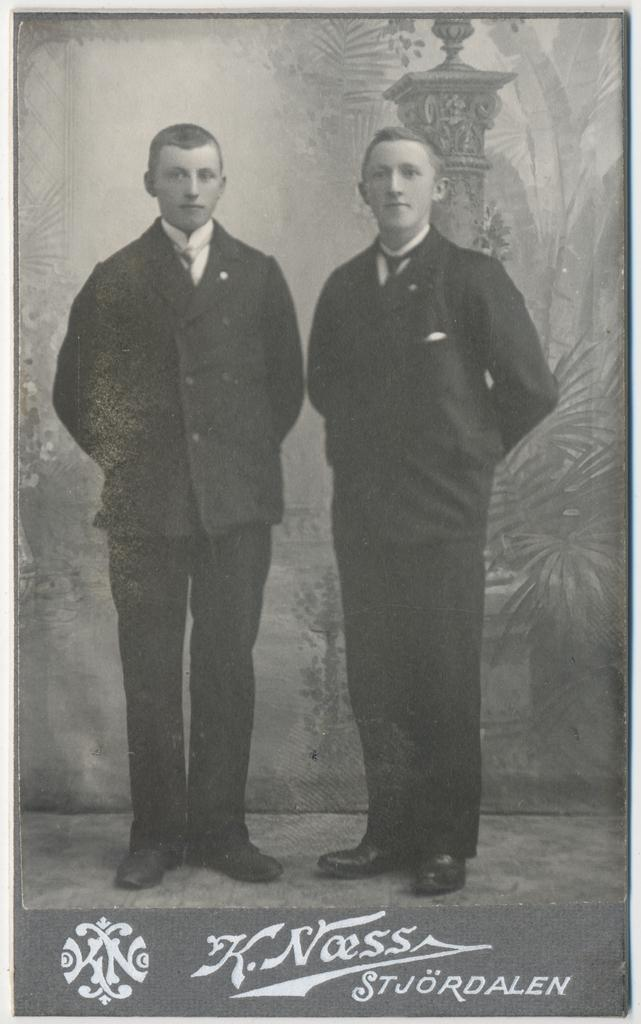How many people are present in the image? There are two persons standing in the image. What can be seen in the background of the image? There is a wall poster in the background of the image. Is there any additional information about the image itself? Yes, there is a watermark on the image. What type of lock can be seen on the carriage in the image? There is no carriage or lock present in the image. How many turkeys are visible in the image? There are no turkeys present in the image. 